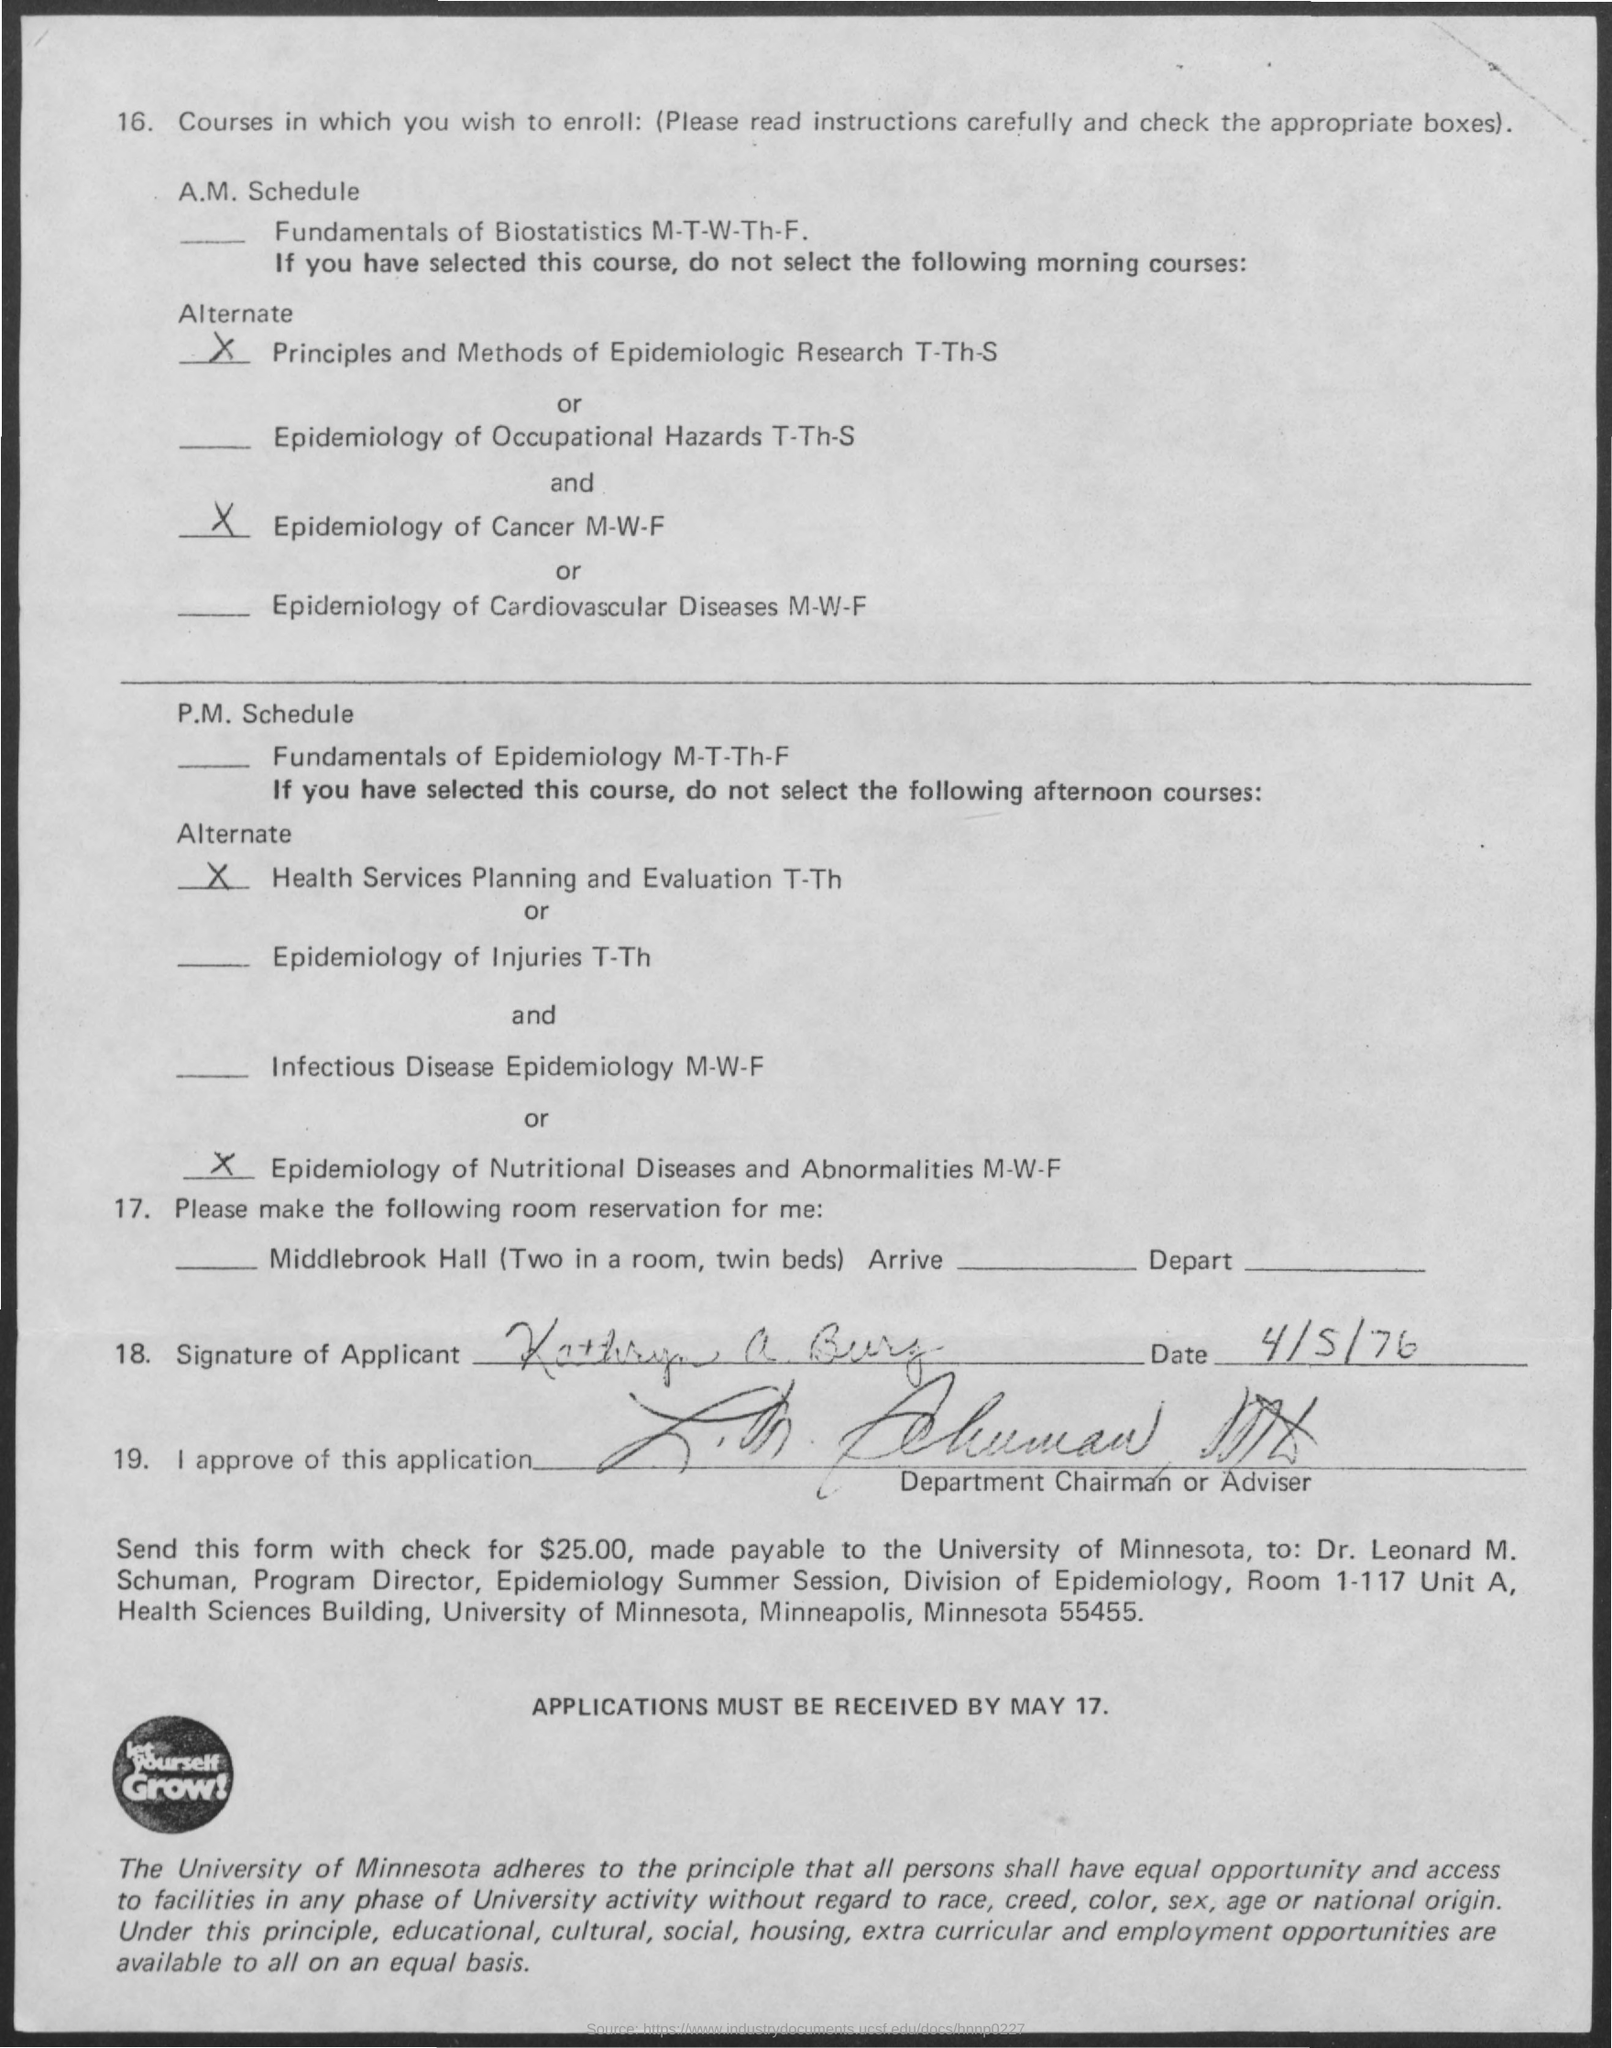Point out several critical features in this image. The name of the university is the University of Minnesota. The applications must be submitted by May 17. On what date is mentioned 4/5/76? Dr. Leonard M. Schuman is the program director for the epidemiology summer session. The amount to be sent in the check is $25.00. 